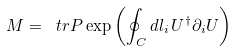Convert formula to latex. <formula><loc_0><loc_0><loc_500><loc_500>M = \ t r P \exp \left ( \oint _ { C } d l _ { i } \, U ^ { \dagger } \partial _ { i } U \right )</formula> 